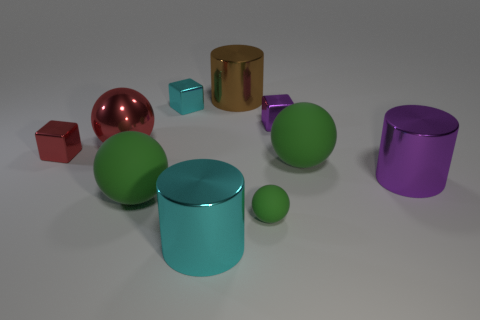There is a ball that is behind the large purple cylinder and to the right of the large brown object; what is its color?
Your answer should be compact. Green. Do the cyan shiny object behind the purple block and the tiny green matte ball have the same size?
Your answer should be very brief. Yes. Is the number of tiny metal objects that are on the left side of the tiny rubber ball greater than the number of metallic cylinders?
Give a very brief answer. No. Is the shape of the tiny purple thing the same as the large purple shiny object?
Your response must be concise. No. What size is the metallic ball?
Make the answer very short. Large. Are there more metallic cubes that are behind the big brown metallic thing than big purple shiny objects that are behind the purple cube?
Make the answer very short. No. There is a tiny green matte ball; are there any shiny objects behind it?
Provide a short and direct response. Yes. Are there any red balls of the same size as the purple metal cylinder?
Provide a succinct answer. Yes. What is the color of the ball that is the same material as the purple cylinder?
Ensure brevity in your answer.  Red. What material is the big cyan object?
Provide a short and direct response. Metal. 